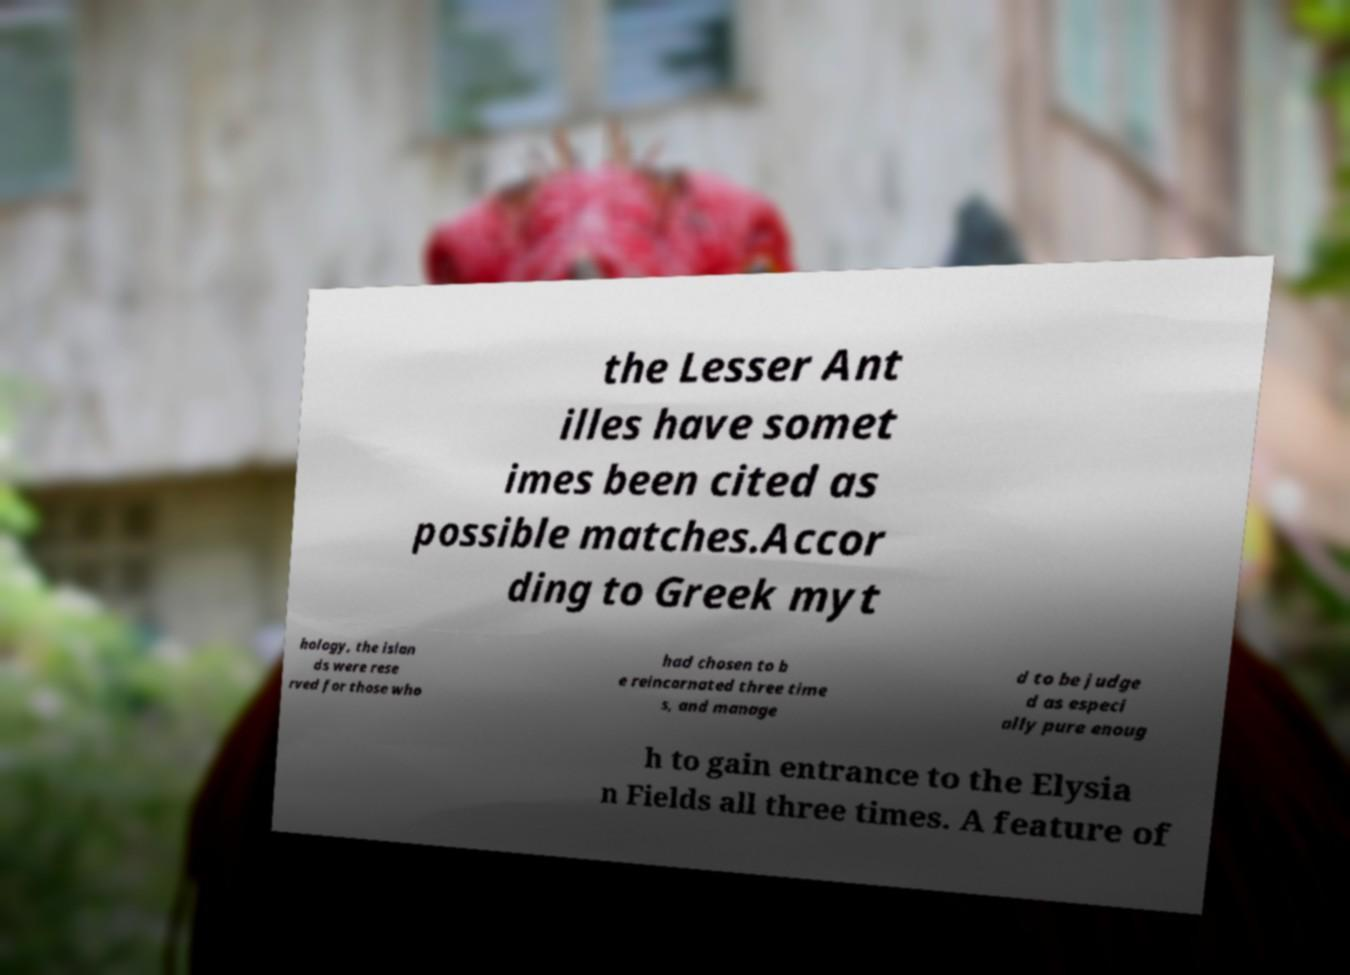Please identify and transcribe the text found in this image. the Lesser Ant illes have somet imes been cited as possible matches.Accor ding to Greek myt hology, the islan ds were rese rved for those who had chosen to b e reincarnated three time s, and manage d to be judge d as especi ally pure enoug h to gain entrance to the Elysia n Fields all three times. A feature of 